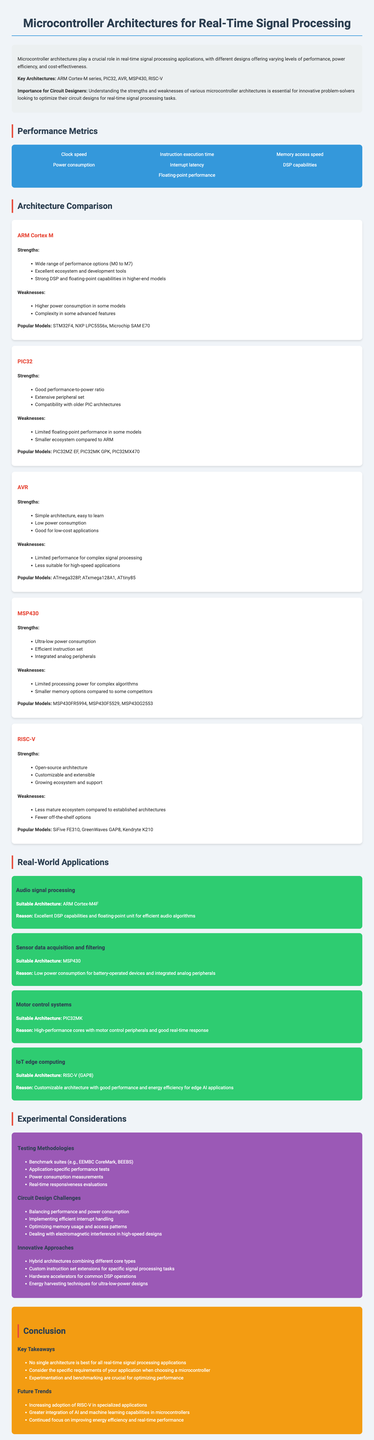What are the key architectures discussed? The document lists the key architectures for real-time signal processing applications, which include ARM Cortex-M series, PIC32, AVR, MSP430, and RISC-V.
Answer: ARM Cortex-M series, PIC32, AVR, MSP430, RISC-V What is a notable strength of the ARM Cortex-M architecture? The document mentions that a notable strength of the ARM Cortex-M architecture is its wide range of performance options from M0 to M7.
Answer: Wide range of performance options Which architecture is suitable for low power consumption applications? The document states that the MSP430 architecture is suitable for low power consumption applications, especially in battery-operated devices.
Answer: MSP430 What performance metric does the document mention related to interrupt handling? The document includes interrupt latency as one of the performance metrics critical for evaluating microcontroller performance.
Answer: Interrupt latency Which architecture has a smaller ecosystem compared to ARM? The document indicates that the PIC32 architecture has a smaller ecosystem compared to ARM.
Answer: PIC32 What is a potential innovative approach mentioned in the report? The document lists hybrid architectures combining different core types as one of the innovative approaches for circuit design.
Answer: Hybrid architectures How many popular models does the AVR architecture have listed? The document specifies three popular models for the AVR architecture: ATmega328P, ATxmega128A1, and ATtiny85.
Answer: Three What is a future trend in microcontroller design according to the document? The document highlights the increasing adoption of RISC-V in specialized applications as a future trend in microcontroller design.
Answer: Increasing adoption of RISC-V Which testing methodology is recommended in the experimental considerations? The document mentions benchmark suites, such as EEMBC CoreMark and BEEBS, as recommended testing methodologies.
Answer: Benchmark suites 